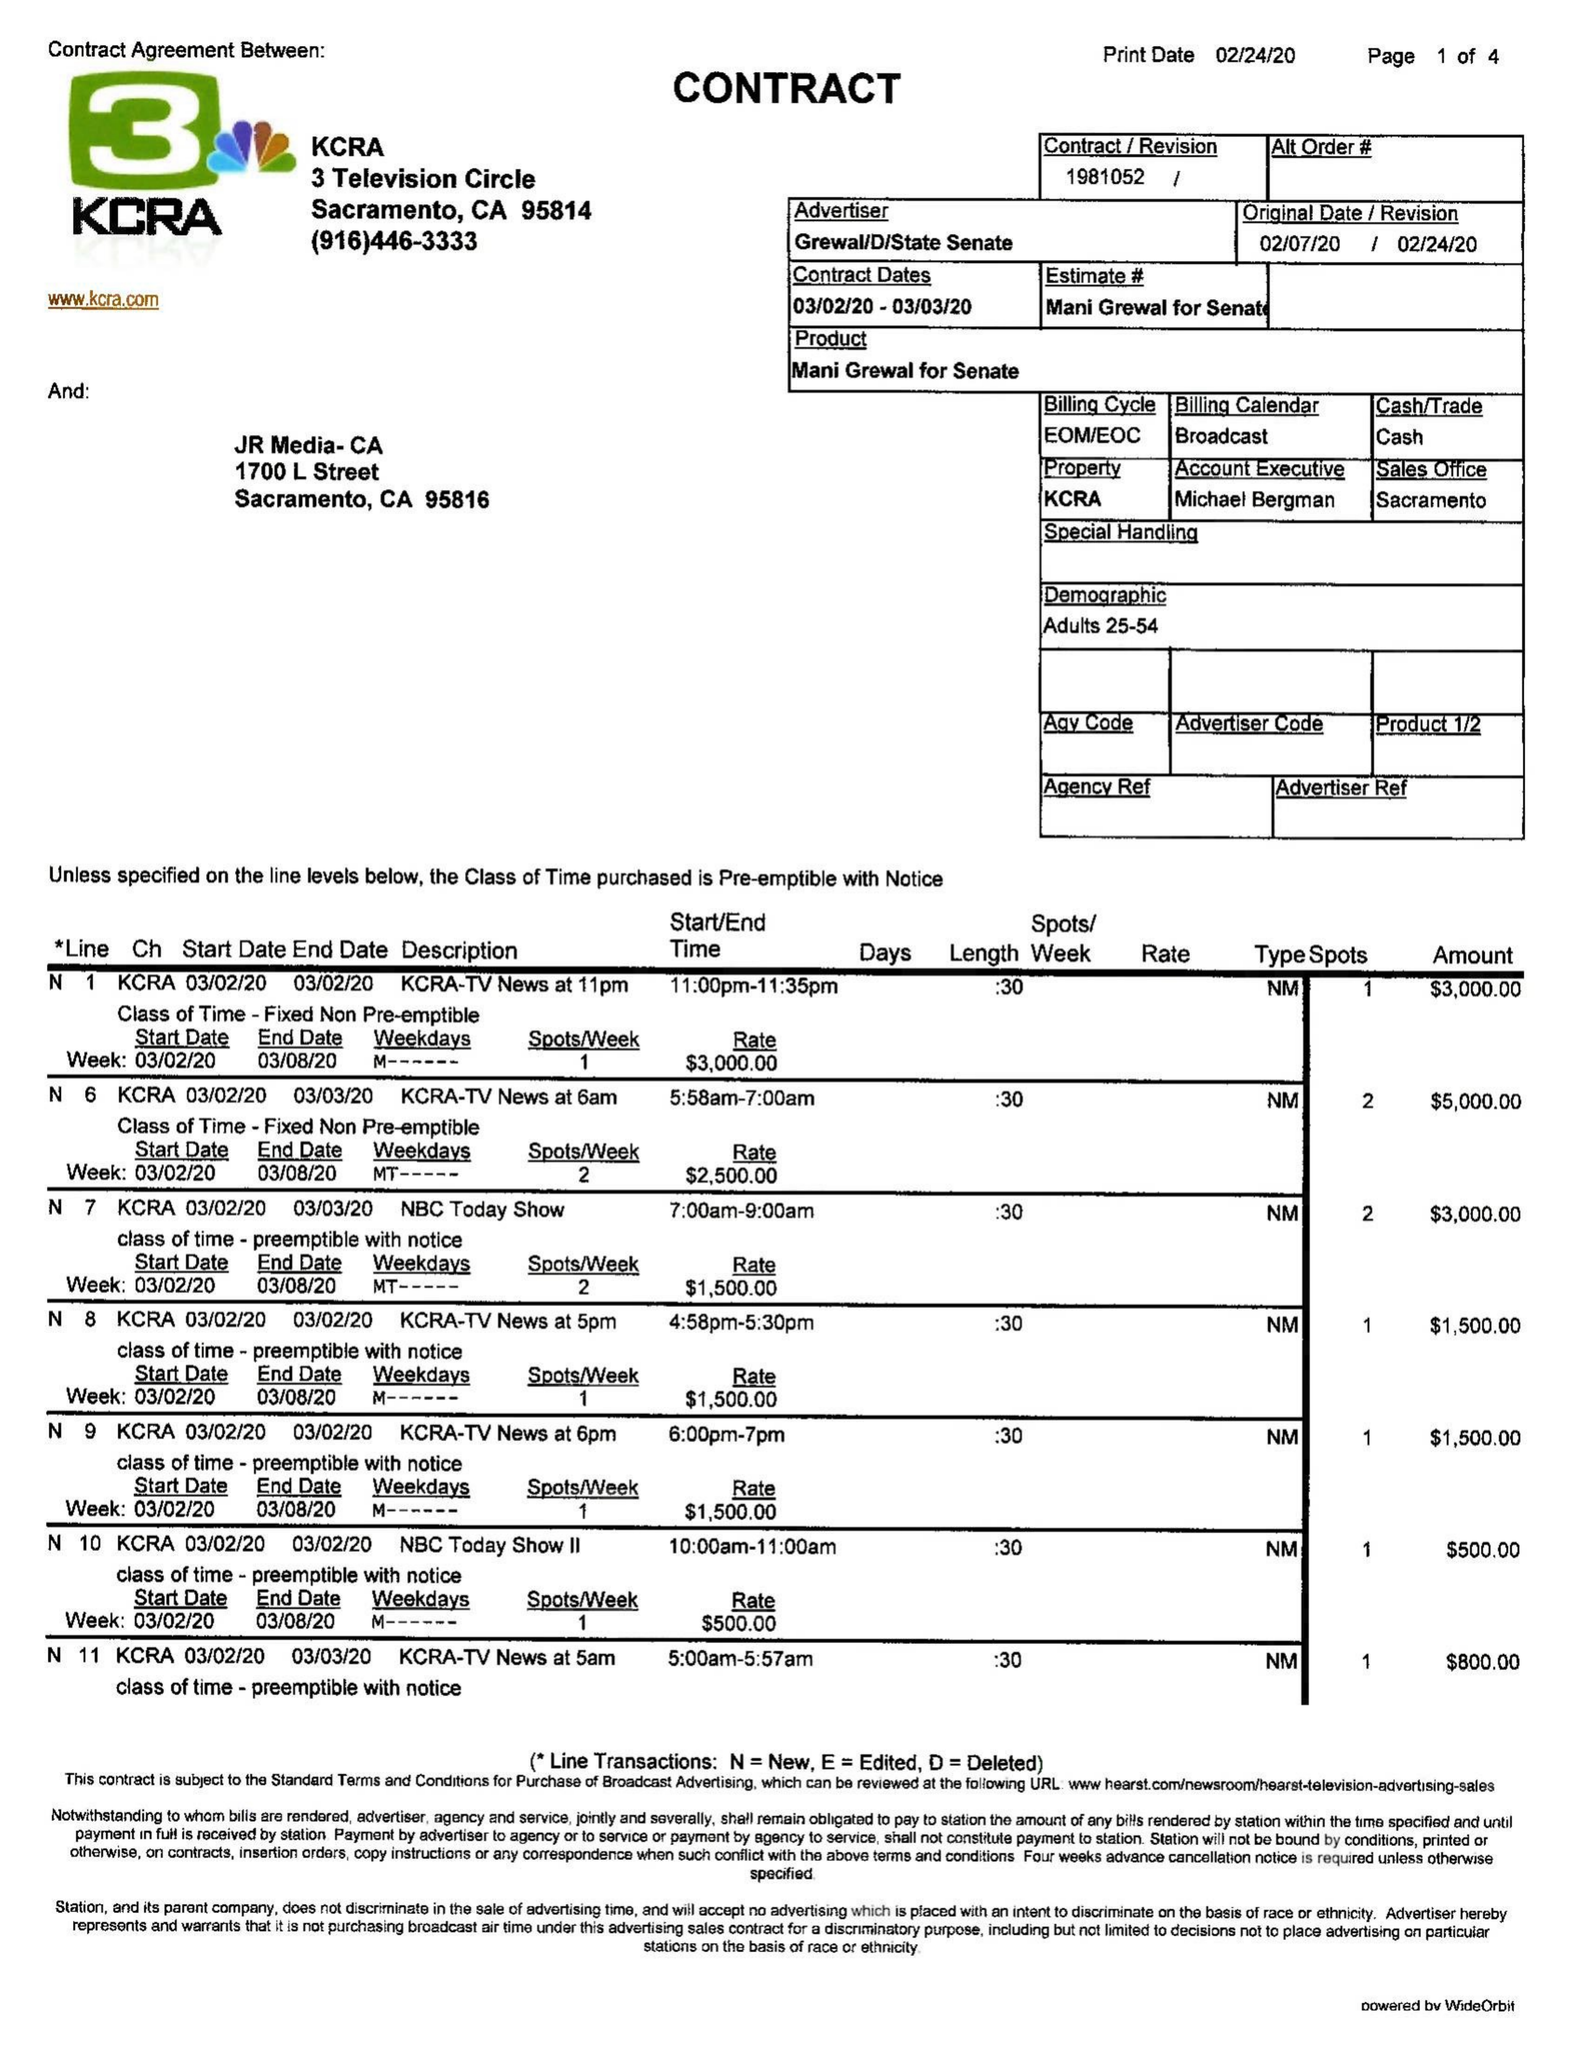What is the value for the flight_to?
Answer the question using a single word or phrase. 03/03/20 